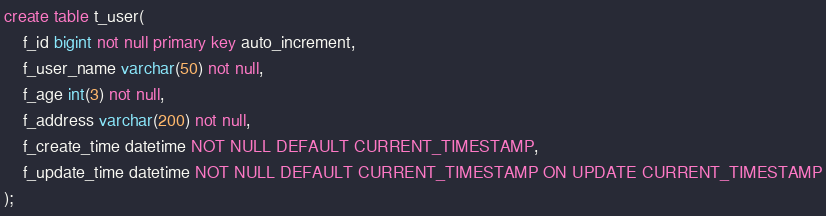Convert code to text. <code><loc_0><loc_0><loc_500><loc_500><_SQL_>create table t_user(
    f_id bigint not null primary key auto_increment,
    f_user_name varchar(50) not null,
    f_age int(3) not null,
    f_address varchar(200) not null,
    f_create_time datetime NOT NULL DEFAULT CURRENT_TIMESTAMP,
    f_update_time datetime NOT NULL DEFAULT CURRENT_TIMESTAMP ON UPDATE CURRENT_TIMESTAMP
);</code> 